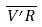<formula> <loc_0><loc_0><loc_500><loc_500>\overline { V ^ { \prime } R }</formula> 